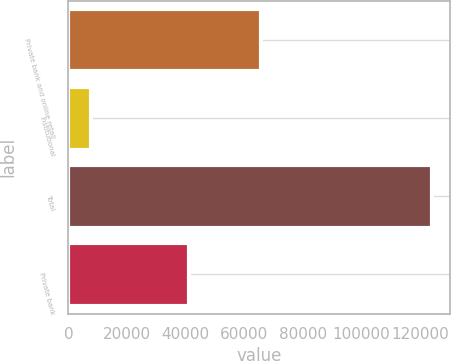Convert chart. <chart><loc_0><loc_0><loc_500><loc_500><bar_chart><fcel>Private bank and online retail<fcel>Institutional<fcel>Total<fcel>Private bank<nl><fcel>65603<fcel>7571<fcel>124098<fcel>41069<nl></chart> 